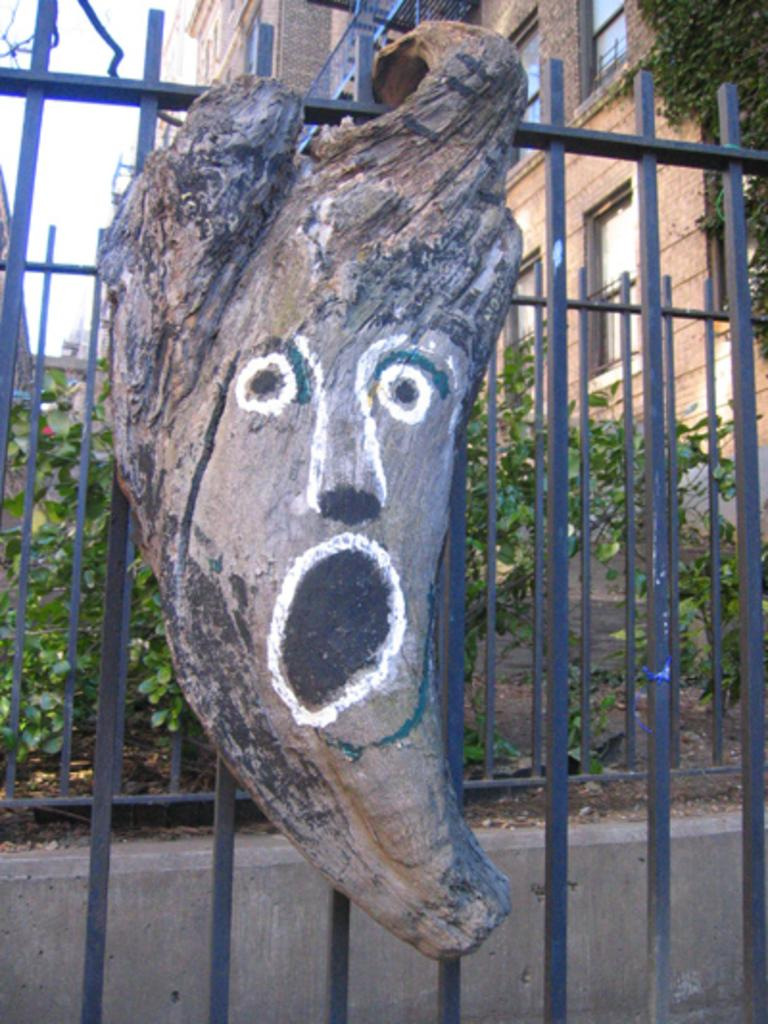What is depicted on the wooden trunk in the image? There is a painting on a wooden trunk in the image. How is the wooden trunk positioned in the image? The wooden trunk is hanged on a metal fence. What can be seen in the background of the image? There are buildings, plants, trees, and the sky visible in the background of the image. Can you see a river flowing in the background of the image? There is no river visible in the background of the image. How far does the hydrant stretch in the image? There is no hydrant present in the image. 